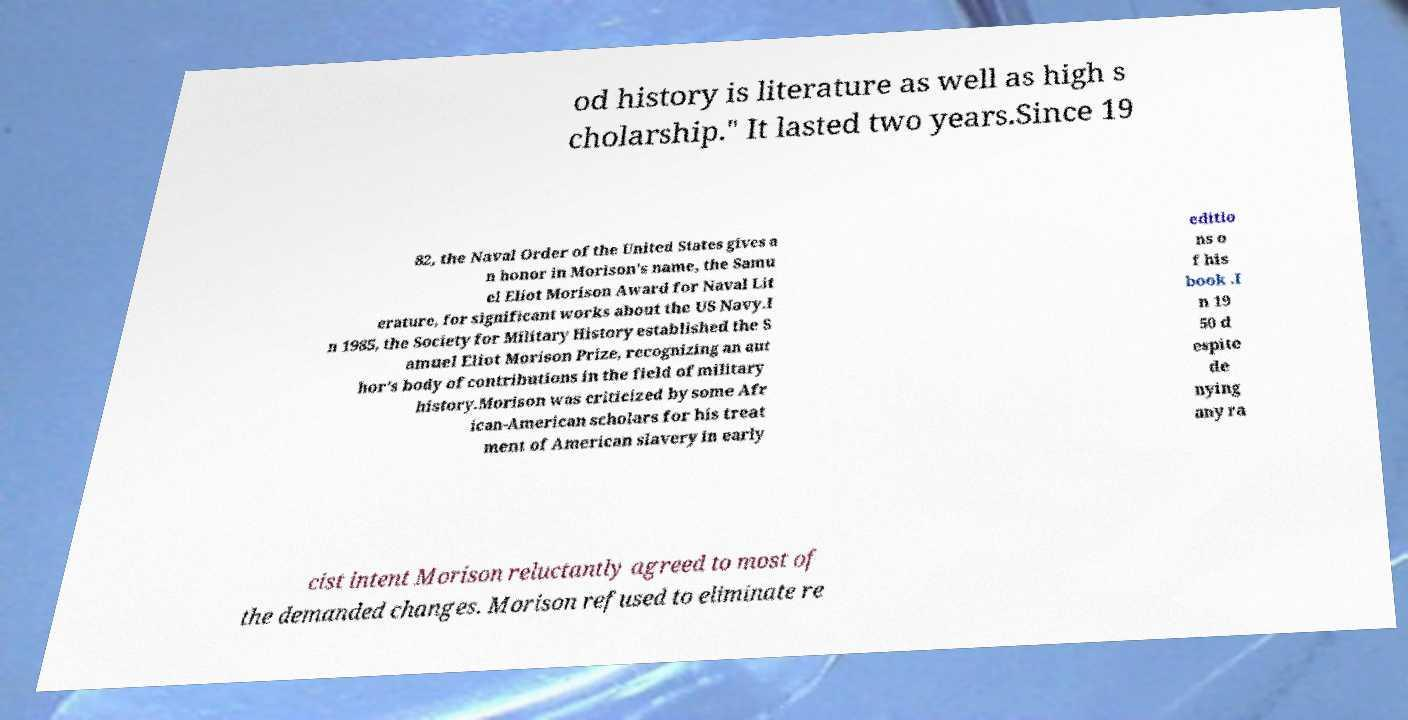Please identify and transcribe the text found in this image. od history is literature as well as high s cholarship." It lasted two years.Since 19 82, the Naval Order of the United States gives a n honor in Morison's name, the Samu el Eliot Morison Award for Naval Lit erature, for significant works about the US Navy.I n 1985, the Society for Military History established the S amuel Eliot Morison Prize, recognizing an aut hor's body of contributions in the field of military history.Morison was criticized by some Afr ican-American scholars for his treat ment of American slavery in early editio ns o f his book .I n 19 50 d espite de nying any ra cist intent Morison reluctantly agreed to most of the demanded changes. Morison refused to eliminate re 